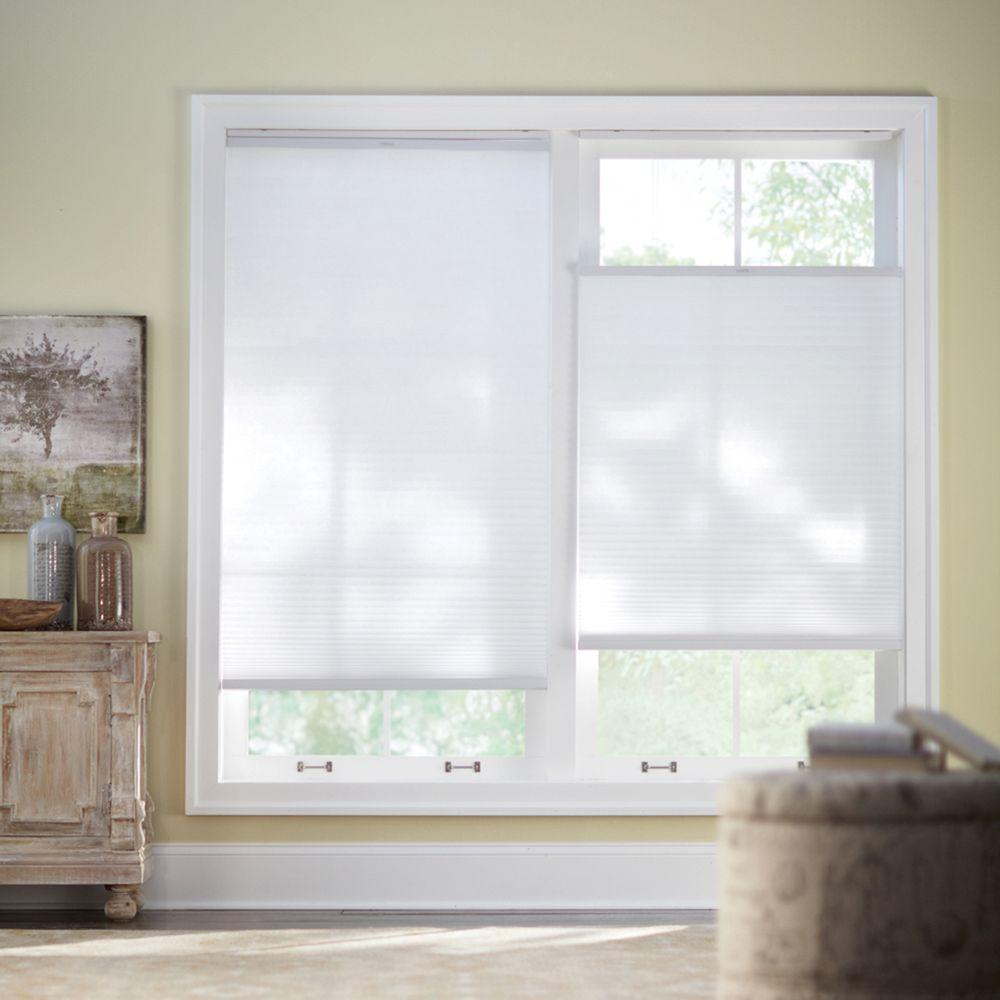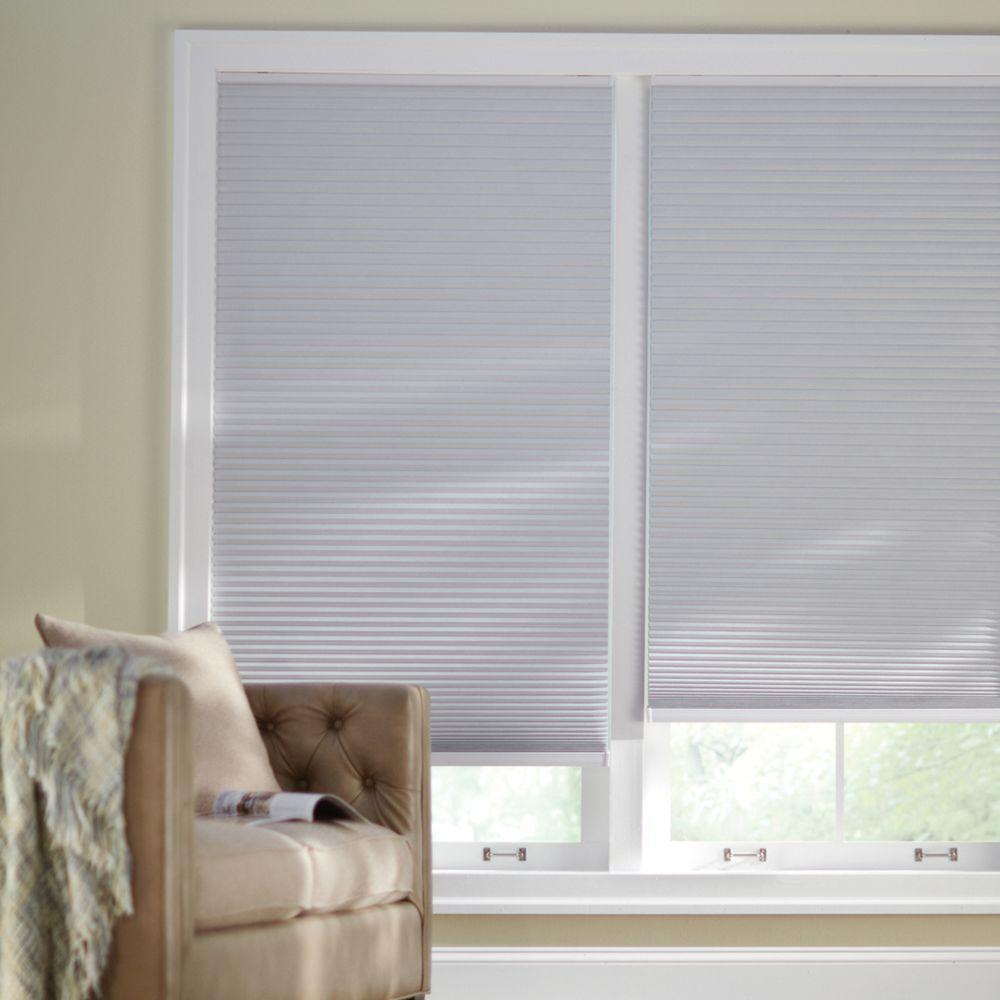The first image is the image on the left, the second image is the image on the right. For the images displayed, is the sentence "An image shows a tufted chair on the left in front of side-by-side windows with shades that are not fully closed." factually correct? Answer yes or no. Yes. The first image is the image on the left, the second image is the image on the right. For the images shown, is this caption "There is a table in the right image, and a light to the left of the table." true? Answer yes or no. No. 